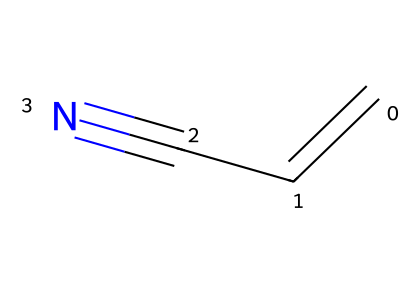What is the molecular formula of acrylonitrile? The chemical structure indicates that there are three carbon atoms (C), three hydrogen atoms (H), and one nitrogen atom (N), leading to the molecular formula C3H3N.
Answer: C3H3N How many double bonds are present in this molecule? The structure shows that there is one double bond between the first two carbon atoms, making it one double bond.
Answer: 1 What functional group is present in acrylonitrile? The presence of the cyano group (-C≡N) at the end of the chain indicates that the functional group is a nitrile.
Answer: nitrile What is the reactivity of the nitrile functional group under typical conditions? Nitriles generally undergo nucleophilic addition reactions, typically reacting with Grignard reagents or undergoing hydrolysis to form carboxylic acids, indicating their moderate reactivity.
Answer: moderate How many total bonds are present in acrylonitrile? The molecule has a total of six bonds: three C-H, one C=C, and one C≡N bond, totaling to six.
Answer: 6 Which type of reaction can acrylonitrile undergo to form a polymer? Acrylonitrile can undergo addition polymerization, reacting with itself under certain conditions to form polyacrylonitrile.
Answer: addition polymerization 